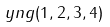<formula> <loc_0><loc_0><loc_500><loc_500>\ y n g ( 1 , 2 , 3 , 4 )</formula> 